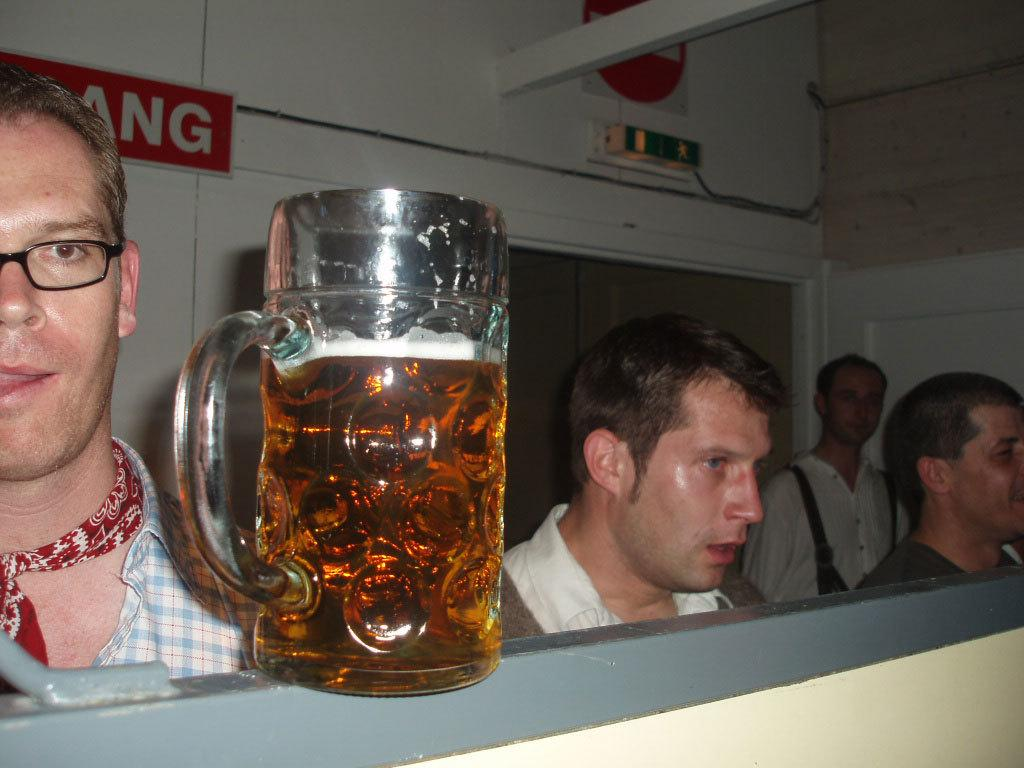What is in the glass that is visible in the image? There is a glass of beer in the image. What is the glass of beer placed on? The glass of beer is on an object. How many people are standing in the image? There are four persons standing in the image. What type of surface can be seen in the image? There are boards visible in the image. What is visible in the background of the image? There is a wall in the background of the image. What color is the stocking on the person's eyes in the image? There is no stocking or person's eyes mentioned in the provided facts, so we cannot answer this question based on the image. 